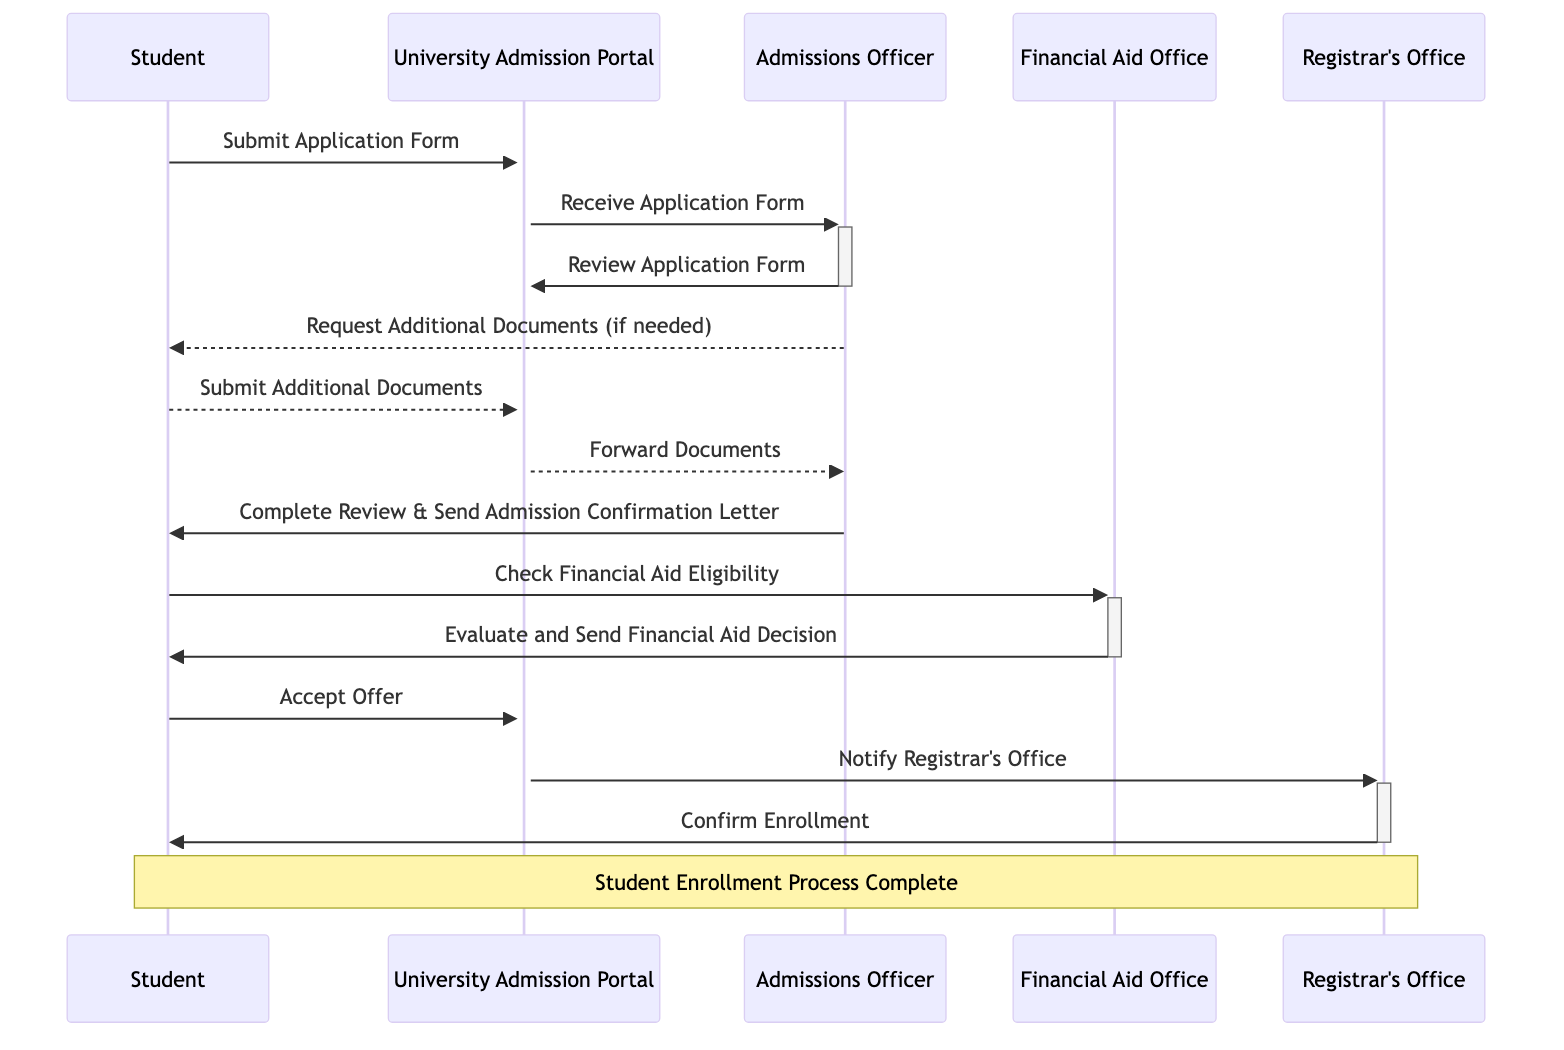What is the first action taken by the Student? The Student initiates the process by submitting the "Application Form" to the University Admission Portal. This is the first action represented in the diagram.
Answer: Submit Application How many actors are involved in the enrollment process? The diagram lists five distinct actors: Student, University Admission Portal, Admissions Officer, Financial Aid Office, and Registrar's Office. Adding these gives a total of five actors.
Answer: Five Who receives the "Application Form" after it is submitted? After the Student submits the "Application Form," it is received by the University Admission Portal, which then forwards it to the Admissions Officer. Thus, University Admission Portal is the entity that initially receives the Application Form.
Answer: University Admission Portal What action does the Admissions Officer take towards the Student if additional documents are needed? If the Admissions Officer finds that additional documents are needed during the review process, they will request these documents from the Student. This flow illustrates the interaction to ensure all necessary information is collected.
Answer: Request Additional Documents What does the Financial Aid Office provide after evaluating the Student's application? Following the evaluation of the Student's application for financial aid eligibility, the Financial Aid Office provides a "Financial Aid Decision" back to the Student. This key output indicates the decision making regarding financial assistance.
Answer: Financial Aid Decision How does the process conclude for the Student? The end of the process for the Student is indicated when they receive confirmation of their enrollment from the Registrar's Office after the necessary actions have been completed by the University Admission Portal.
Answer: Confirm Enrollment Which actor confirms the enrollment of the Student? The final confirmation of the Student's enrollment is conducted by the Registrar's Office, which communicates this information to the Student at the end of the sequence.
Answer: Registrar's Office What document is sent to the Student after the Admissions Officer completes the review? After the Admissions Officer completes the review process, they send the Student the "Admission Confirmation Letter," which signifies the outcome of their application review.
Answer: Admission Confirmation Letter 